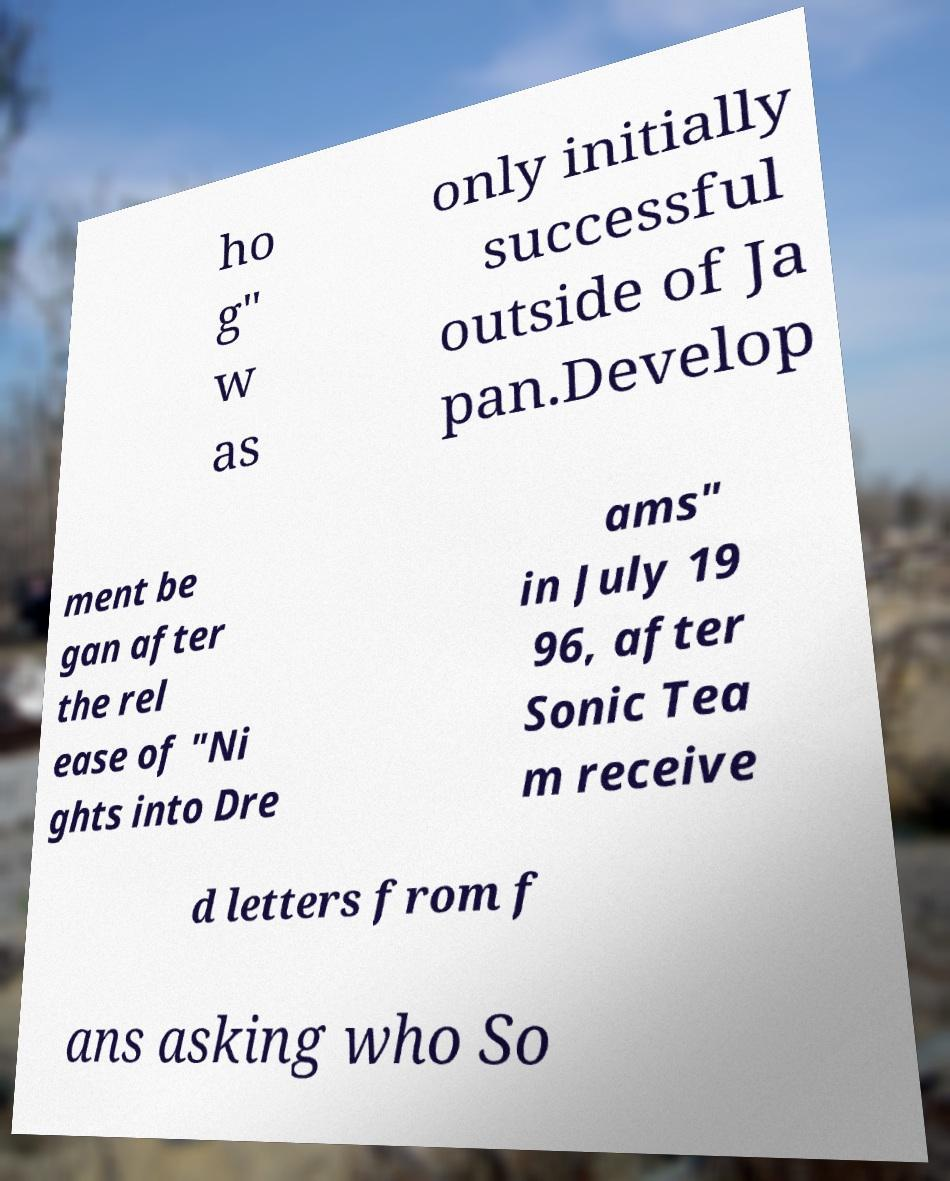Could you extract and type out the text from this image? ho g" w as only initially successful outside of Ja pan.Develop ment be gan after the rel ease of "Ni ghts into Dre ams" in July 19 96, after Sonic Tea m receive d letters from f ans asking who So 